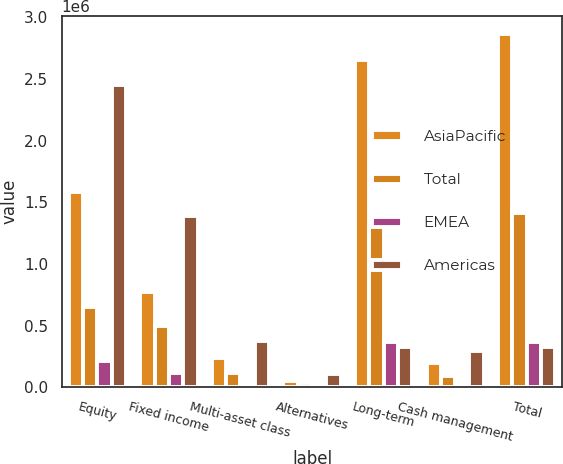<chart> <loc_0><loc_0><loc_500><loc_500><stacked_bar_chart><ecel><fcel>Equity<fcel>Fixed income<fcel>Multi-asset class<fcel>Alternatives<fcel>Long-term<fcel>Cash management<fcel>Total<nl><fcel>AsiaPacific<fcel>1.58353e+06<fcel>774296<fcel>237436<fcel>56668<fcel>2.65193e+06<fcel>199887<fcel>2.86735e+06<nl><fcel>Total<fcel>655985<fcel>502324<fcel>119353<fcel>36817<fcel>1.31448e+06<fcel>92795<fcel>1.41344e+06<nl><fcel>EMEA<fcel>211594<fcel>117033<fcel>21048<fcel>17755<fcel>367430<fcel>3671<fcel>371101<nl><fcel>Americas<fcel>2.45111e+06<fcel>1.39365e+06<fcel>377837<fcel>111240<fcel>331892<fcel>296353<fcel>331892<nl></chart> 